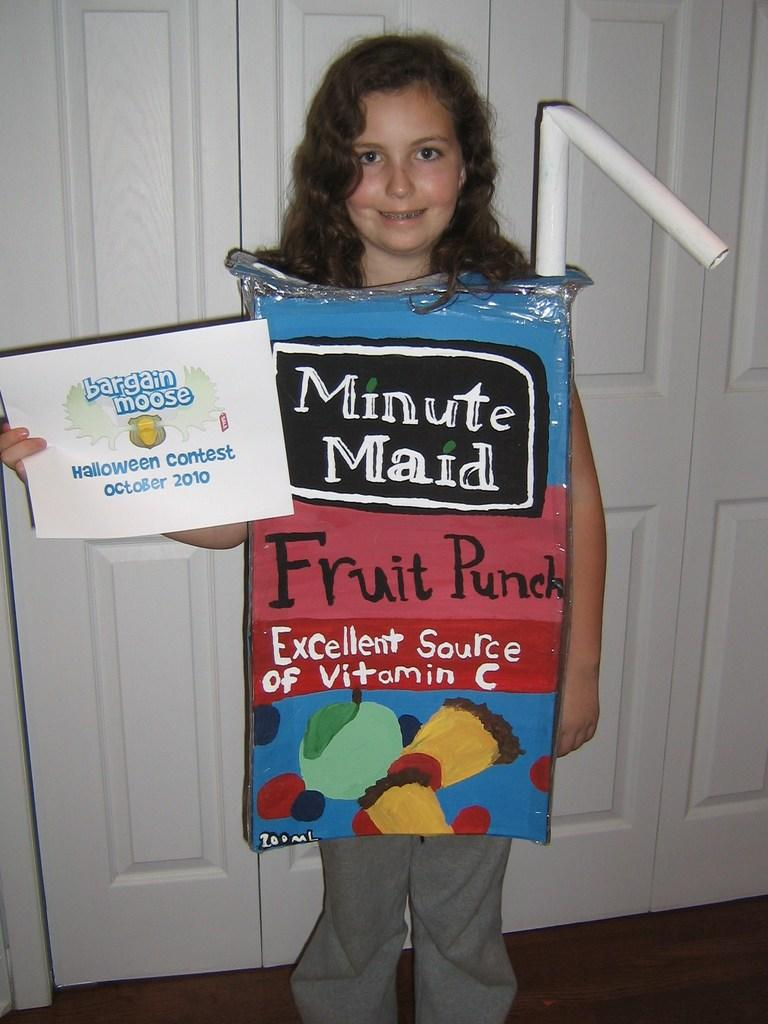What is the main subject of the image? The main subject of the image is a girl child. What is the girl child doing in the image? The girl child is standing and holding a poster. What is on the poster that the girl child is holding? The poster contains information about a contest. What is the girl child wearing in the image? The girl child is wearing a costume. What can be seen in the background of the image? There are white color wooden doors in the background of the image. How many snails can be seen crawling on the girl child's costume in the image? There are no snails visible on the girl child's costume in the image. What change does the girl child make to the poster during the event? The provided facts do not mention any event or change made by the girl child to the poster. 